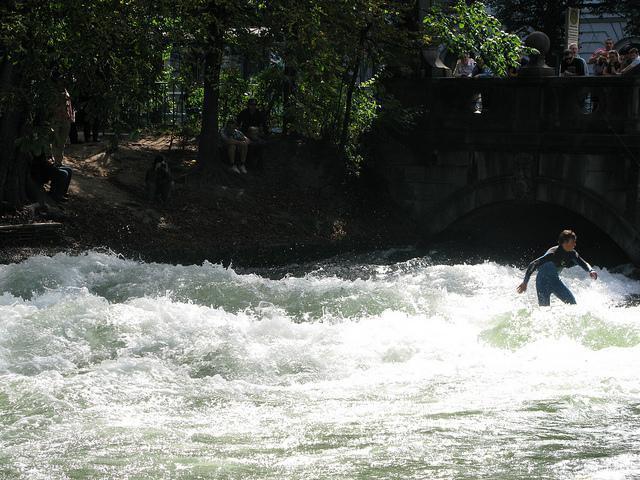How many surfboards are in the picture?
Give a very brief answer. 1. How many zebras are there?
Give a very brief answer. 0. 